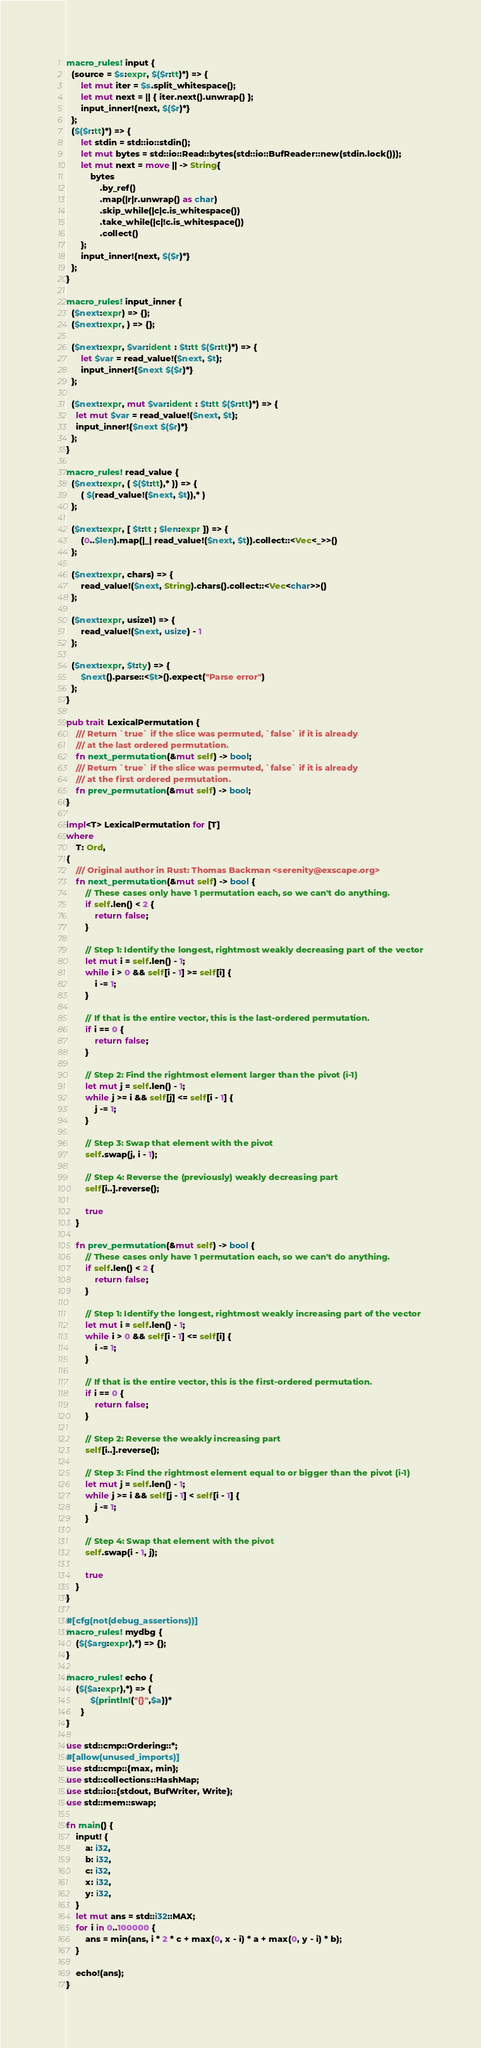<code> <loc_0><loc_0><loc_500><loc_500><_Rust_>macro_rules! input {
  (source = $s:expr, $($r:tt)*) => {
      let mut iter = $s.split_whitespace();
      let mut next = || { iter.next().unwrap() };
      input_inner!{next, $($r)*}
  };
  ($($r:tt)*) => {
      let stdin = std::io::stdin();
      let mut bytes = std::io::Read::bytes(std::io::BufReader::new(stdin.lock()));
      let mut next = move || -> String{
          bytes
              .by_ref()
              .map(|r|r.unwrap() as char)
              .skip_while(|c|c.is_whitespace())
              .take_while(|c|!c.is_whitespace())
              .collect()
      };
      input_inner!{next, $($r)*}
  };
}

macro_rules! input_inner {
  ($next:expr) => {};
  ($next:expr, ) => {};

  ($next:expr, $var:ident : $t:tt $($r:tt)*) => {
      let $var = read_value!($next, $t);
      input_inner!{$next $($r)*}
  };

  ($next:expr, mut $var:ident : $t:tt $($r:tt)*) => {
    let mut $var = read_value!($next, $t);
    input_inner!{$next $($r)*}
  };
}

macro_rules! read_value {
  ($next:expr, ( $($t:tt),* )) => {
      ( $(read_value!($next, $t)),* )
  };

  ($next:expr, [ $t:tt ; $len:expr ]) => {
      (0..$len).map(|_| read_value!($next, $t)).collect::<Vec<_>>()
  };

  ($next:expr, chars) => {
      read_value!($next, String).chars().collect::<Vec<char>>()
  };

  ($next:expr, usize1) => {
      read_value!($next, usize) - 1
  };

  ($next:expr, $t:ty) => {
      $next().parse::<$t>().expect("Parse error")
  };
}

pub trait LexicalPermutation {
    /// Return `true` if the slice was permuted, `false` if it is already
    /// at the last ordered permutation.
    fn next_permutation(&mut self) -> bool;
    /// Return `true` if the slice was permuted, `false` if it is already
    /// at the first ordered permutation.
    fn prev_permutation(&mut self) -> bool;
}

impl<T> LexicalPermutation for [T]
where
    T: Ord,
{
    /// Original author in Rust: Thomas Backman <serenity@exscape.org>
    fn next_permutation(&mut self) -> bool {
        // These cases only have 1 permutation each, so we can't do anything.
        if self.len() < 2 {
            return false;
        }

        // Step 1: Identify the longest, rightmost weakly decreasing part of the vector
        let mut i = self.len() - 1;
        while i > 0 && self[i - 1] >= self[i] {
            i -= 1;
        }

        // If that is the entire vector, this is the last-ordered permutation.
        if i == 0 {
            return false;
        }

        // Step 2: Find the rightmost element larger than the pivot (i-1)
        let mut j = self.len() - 1;
        while j >= i && self[j] <= self[i - 1] {
            j -= 1;
        }

        // Step 3: Swap that element with the pivot
        self.swap(j, i - 1);

        // Step 4: Reverse the (previously) weakly decreasing part
        self[i..].reverse();

        true
    }

    fn prev_permutation(&mut self) -> bool {
        // These cases only have 1 permutation each, so we can't do anything.
        if self.len() < 2 {
            return false;
        }

        // Step 1: Identify the longest, rightmost weakly increasing part of the vector
        let mut i = self.len() - 1;
        while i > 0 && self[i - 1] <= self[i] {
            i -= 1;
        }

        // If that is the entire vector, this is the first-ordered permutation.
        if i == 0 {
            return false;
        }

        // Step 2: Reverse the weakly increasing part
        self[i..].reverse();

        // Step 3: Find the rightmost element equal to or bigger than the pivot (i-1)
        let mut j = self.len() - 1;
        while j >= i && self[j - 1] < self[i - 1] {
            j -= 1;
        }

        // Step 4: Swap that element with the pivot
        self.swap(i - 1, j);

        true
    }
}

#[cfg(not(debug_assertions))]
macro_rules! mydbg {
    ($($arg:expr),*) => {};
}

macro_rules! echo {
    ($($a:expr),*) => {
          $(println!("{}",$a))*
      }
}

use std::cmp::Ordering::*;
#[allow(unused_imports)]
use std::cmp::{max, min};
use std::collections::HashMap;
use std::io::{stdout, BufWriter, Write};
use std::mem::swap;

fn main() {
    input! {
        a: i32,
        b: i32,
        c: i32,
        x: i32,
        y: i32,
    }
    let mut ans = std::i32::MAX;
    for i in 0..100000 {
        ans = min(ans, i * 2 * c + max(0, x - i) * a + max(0, y - i) * b);
    }

    echo!(ans);
}</code> 